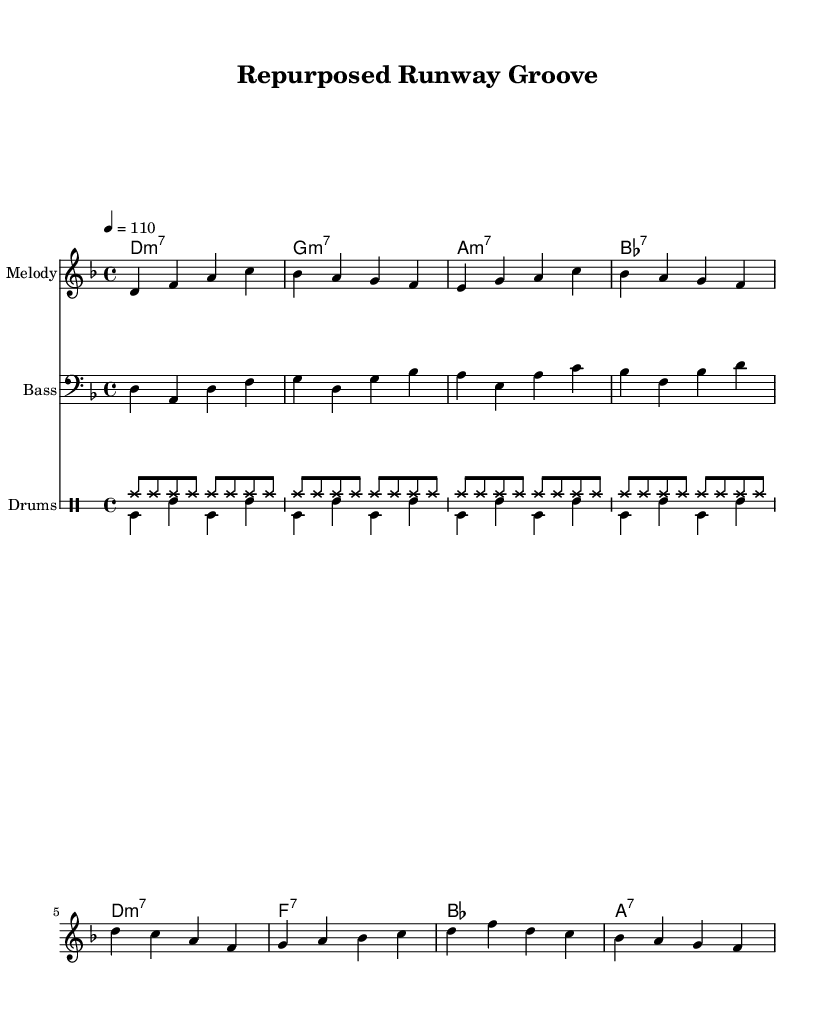What is the key signature of this music? The key signature is D minor, which is indicated by one flat (B flat) in the staff.
Answer: D minor What is the time signature of this music? The time signature is found at the beginning of the music and is displayed as 4/4, meaning there are four beats per measure and the quarter note gets one beat.
Answer: 4/4 What is the tempo marking for this piece? The tempo marking is indicated above the music as "4 = 110," specifying that there should be 110 beats per minute, counted in quarter notes.
Answer: 110 What chord starts the piece? The first chord in the chord progression is a D minor 7 chord, notated as "d:m7," indicating the harmony that accompanies the melody.
Answer: D minor 7 How many different sections are in the drum part? The drum part consists of two sections: one for hi-hat patterns (drumsUp) and one for bass drum and snare patterns (drumsDown), making a total of two distinct sections.
Answer: 2 What is the highest note in the melody line? The highest note in the melody line is D, which appears as a high D (d') in the first measure of the melody.
Answer: D What type of groove does this piece represent? This piece showcases a funk groove, characterized by the syncopated rhythms and the energetic feel, which is a distinctive feature of the funk genre.
Answer: Funk 